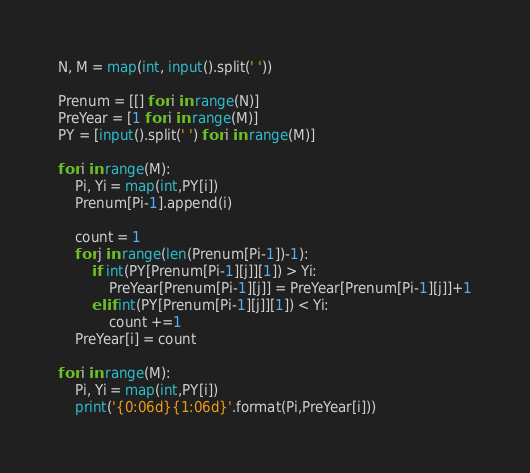<code> <loc_0><loc_0><loc_500><loc_500><_Python_>N, M = map(int, input().split(' '))

Prenum = [[] for i in range(N)]
PreYear = [1 for i in range(M)]
PY = [input().split(' ') for i in range(M)]

for i in range(M):
    Pi, Yi = map(int,PY[i])
    Prenum[Pi-1].append(i)

    count = 1
    for j in range(len(Prenum[Pi-1])-1):
        if int(PY[Prenum[Pi-1][j]][1]) > Yi:
            PreYear[Prenum[Pi-1][j]] = PreYear[Prenum[Pi-1][j]]+1
        elif int(PY[Prenum[Pi-1][j]][1]) < Yi:
            count +=1 
    PreYear[i] = count

for i in range(M):
    Pi, Yi = map(int,PY[i])
    print('{0:06d}{1:06d}'.format(Pi,PreYear[i]))</code> 